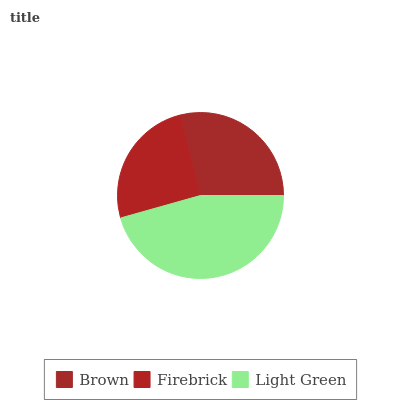Is Firebrick the minimum?
Answer yes or no. Yes. Is Light Green the maximum?
Answer yes or no. Yes. Is Light Green the minimum?
Answer yes or no. No. Is Firebrick the maximum?
Answer yes or no. No. Is Light Green greater than Firebrick?
Answer yes or no. Yes. Is Firebrick less than Light Green?
Answer yes or no. Yes. Is Firebrick greater than Light Green?
Answer yes or no. No. Is Light Green less than Firebrick?
Answer yes or no. No. Is Brown the high median?
Answer yes or no. Yes. Is Brown the low median?
Answer yes or no. Yes. Is Firebrick the high median?
Answer yes or no. No. Is Firebrick the low median?
Answer yes or no. No. 